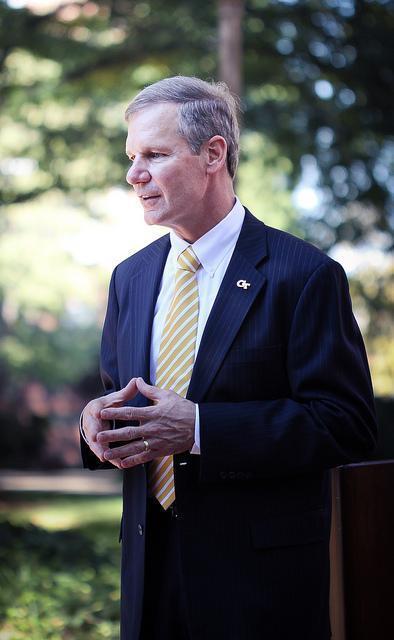How many person is wearing orange color t-shirt?
Give a very brief answer. 0. 